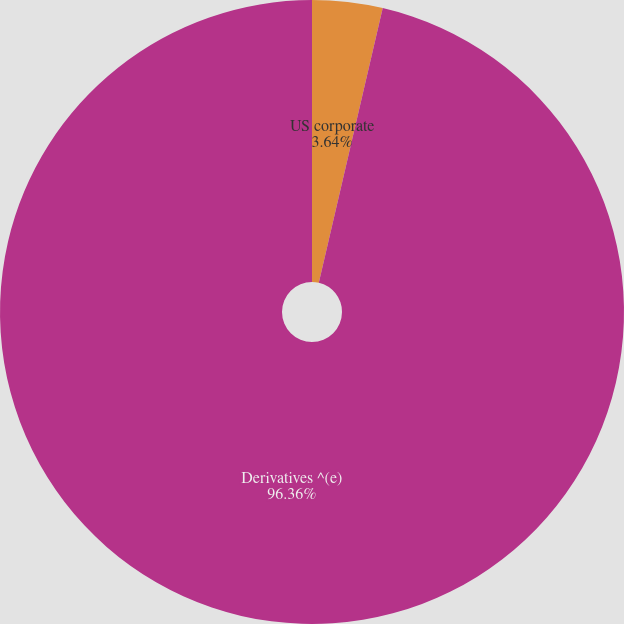Convert chart. <chart><loc_0><loc_0><loc_500><loc_500><pie_chart><fcel>US corporate<fcel>Derivatives ^(e)<nl><fcel>3.64%<fcel>96.36%<nl></chart> 